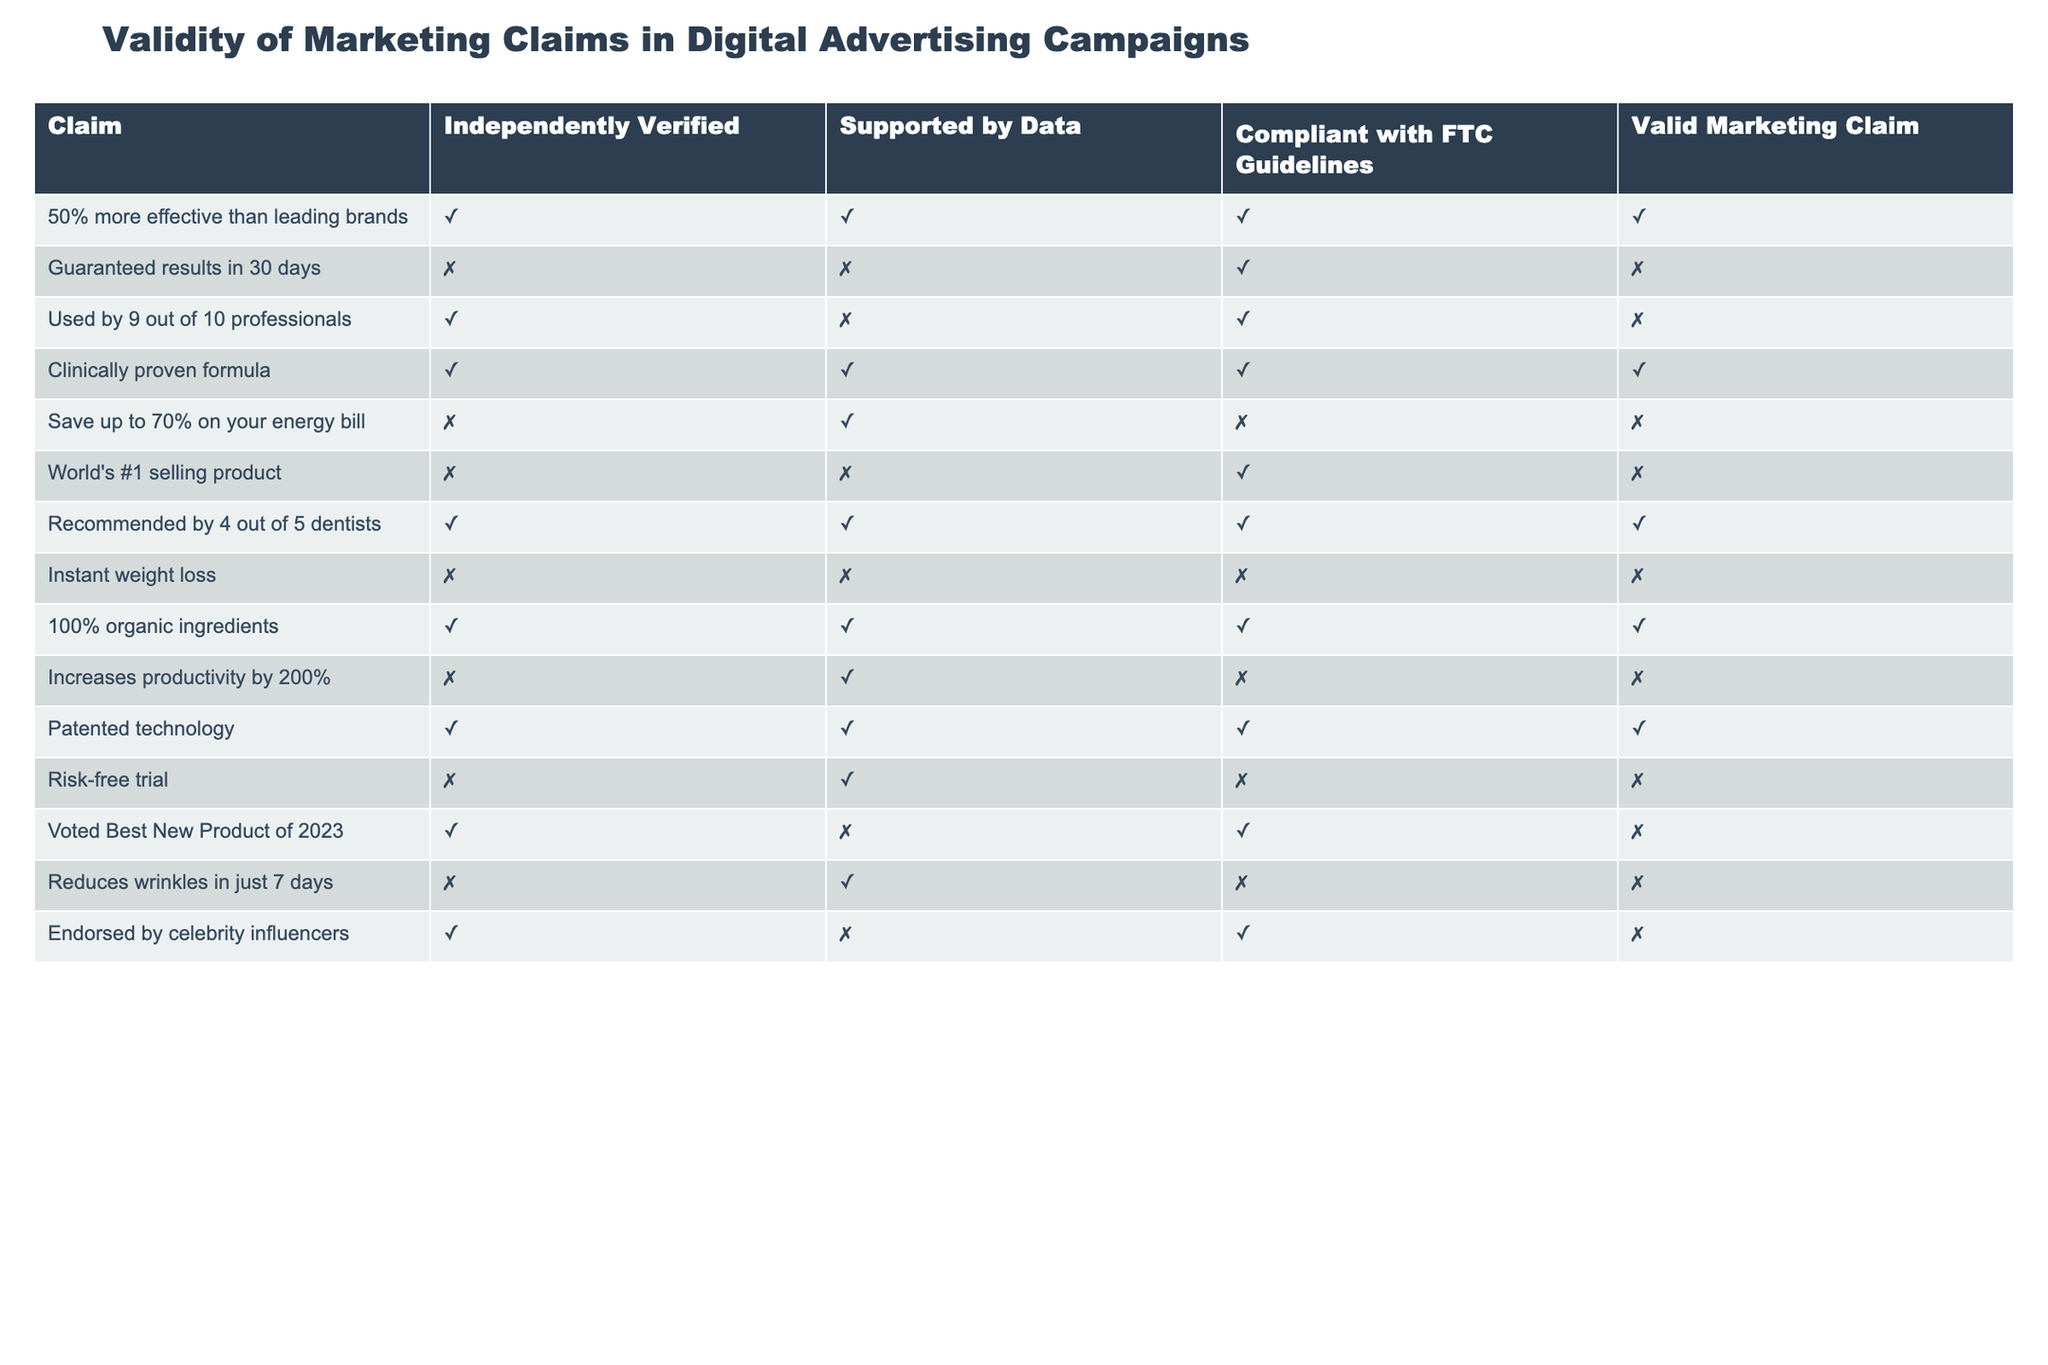What is the claim that is supported by data but not independently verified? The claim "Used by 9 out of 10 professionals" is marked as TRUE for being independently verified and FALSE for being supported by data. This means it is supported by data but not independently verified.
Answer: "Used by 9 out of 10 professionals" How many claims are valid marketing claims according to the table? From the table, the valid marketing claims are: "50% more effective than leading brands", "Clinically proven formula", "Recommended by 4 out of 5 dentists", "100% organic ingredients", "Patented technology". This gives a total of 5 valid claims.
Answer: 5 Is the claim "Instant weight loss" compliant with FTC guidelines? The claim "Instant weight loss" is marked as FALSE under the column "Compliant with FTC Guidelines", indicating that it does not comply.
Answer: No Which claim boasts being the "World's #1 selling product," and is it valid? The "World's #1 selling product" claim is marked as FALSE for independently verified, supported by data, and compliant with FTC guidelines. Thus, it is not a valid marketing claim.
Answer: No What percentage of claims are both independently verified and compliant with FTC guidelines? There are 5 claims that are marked TRUE for both independently verified and compliant with FTC guidelines: "50% more effective than leading brands," "Clinically proven formula," "Recommended by 4 out of 5 dentists," "100% organic ingredients," and "Patented technology." Out of the total 14 claims, the percentage is (5/14) * 100, which equals about 35.71%.
Answer: Approximately 35.71% Which claim has the highest impact on effectiveness according to the table, and why? The claim "Increases productivity by 200%" is marked as FALSE for both independently verified and compliant with FTC guidelines, portraying it as significantly questionable. It suggests a high impact but lacks verification, undermining its credibility.
Answer: "Increases productivity by 200%" What combinations of characteristics apply to the claim "Risk-free trial"? The claim "Risk-free trial" is marked as FALSE for independently verified, TRUE for supported by data, and FALSE for compliant with FTC guidelines. This combination indicates it lacks independent verification and compliance, even though it is supported by data.
Answer: False for independently verified and compliant, True for supported by data How many claims are both supported by data and not valid marketing claims? The claims that are supported by data but not valid marketing claims are: "Guaranteed results in 30 days," "Save up to 70% on your energy bill," "World's #1 selling product," "Increases productivity by 200%", "Instant weight loss," "Reduces wrinkles in just 7 days," and "Voted Best New Product of 2023." This totals 7 claims.
Answer: 7 Are there any claims that are both independently verified and described as not valid? Yes, there are claims that are independently verified but not valid, specifically "Used by 9 out of 10 professionals" and "Endorsed by celebrity influencers." Both are marked as TRUE for independently verified but FALSE for valid marketing claims.
Answer: Yes 